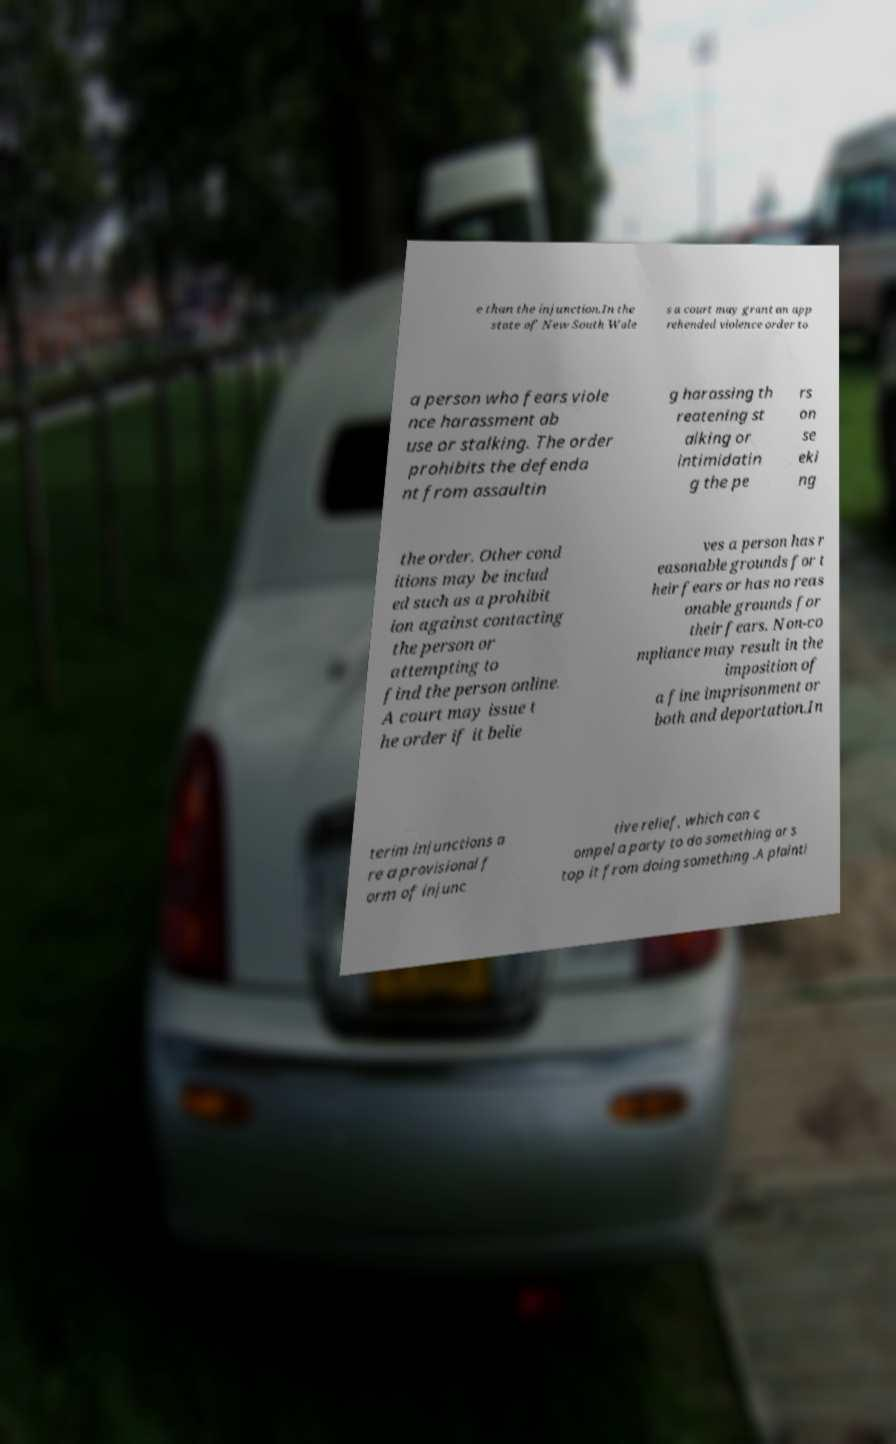Please read and relay the text visible in this image. What does it say? e than the injunction.In the state of New South Wale s a court may grant an app rehended violence order to a person who fears viole nce harassment ab use or stalking. The order prohibits the defenda nt from assaultin g harassing th reatening st alking or intimidatin g the pe rs on se eki ng the order. Other cond itions may be includ ed such as a prohibit ion against contacting the person or attempting to find the person online. A court may issue t he order if it belie ves a person has r easonable grounds for t heir fears or has no reas onable grounds for their fears. Non-co mpliance may result in the imposition of a fine imprisonment or both and deportation.In terim injunctions a re a provisional f orm of injunc tive relief, which can c ompel a party to do something or s top it from doing something .A plainti 